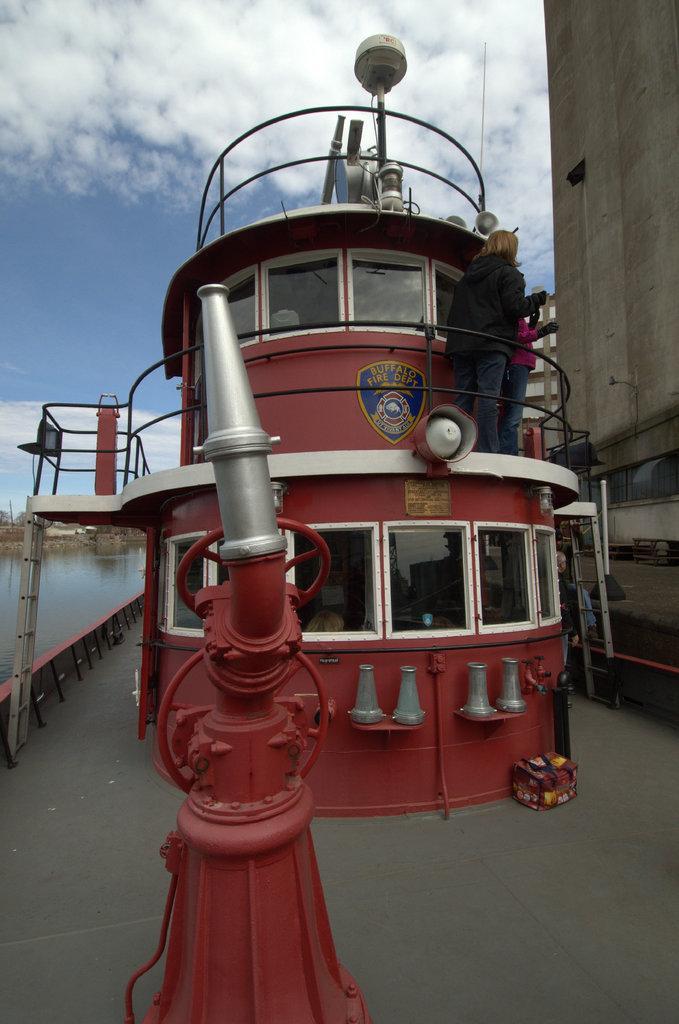In one or two sentences, can you explain what this image depicts? In this image, I think this is a ship. I can see two people standing. These are the clouds in the sky. On the right side of the image. This looks like a wall. I think this is a bag. 